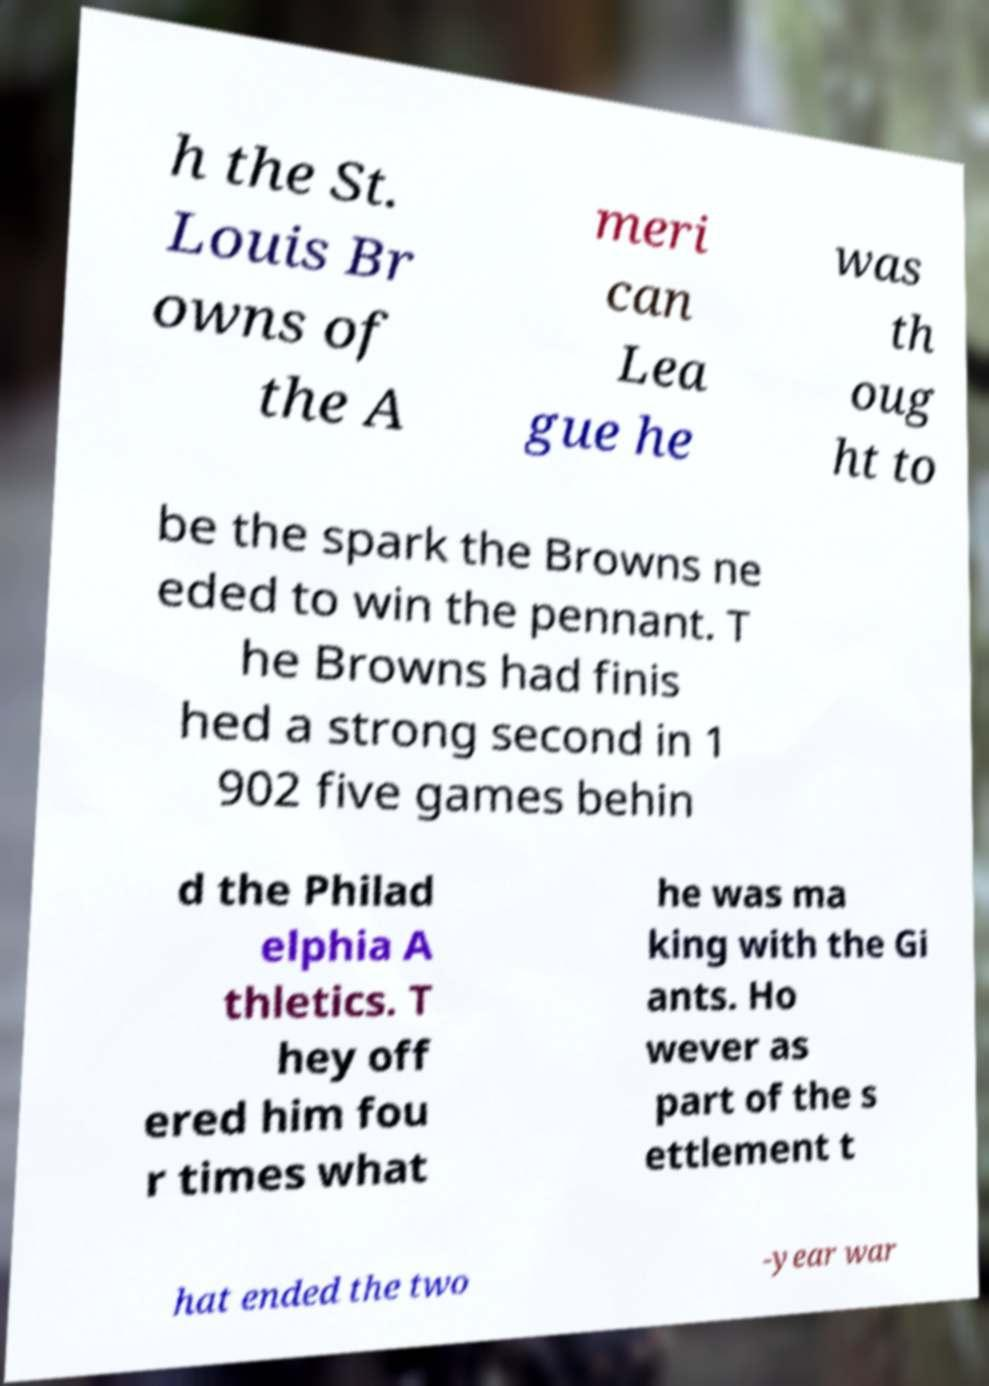Can you read and provide the text displayed in the image?This photo seems to have some interesting text. Can you extract and type it out for me? h the St. Louis Br owns of the A meri can Lea gue he was th oug ht to be the spark the Browns ne eded to win the pennant. T he Browns had finis hed a strong second in 1 902 five games behin d the Philad elphia A thletics. T hey off ered him fou r times what he was ma king with the Gi ants. Ho wever as part of the s ettlement t hat ended the two -year war 